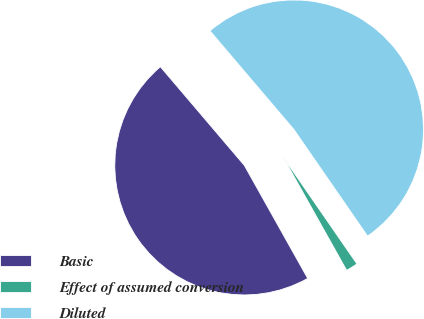<chart> <loc_0><loc_0><loc_500><loc_500><pie_chart><fcel>Basic<fcel>Effect of assumed conversion<fcel>Diluted<nl><fcel>46.91%<fcel>1.49%<fcel>51.6%<nl></chart> 